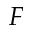<formula> <loc_0><loc_0><loc_500><loc_500>F</formula> 